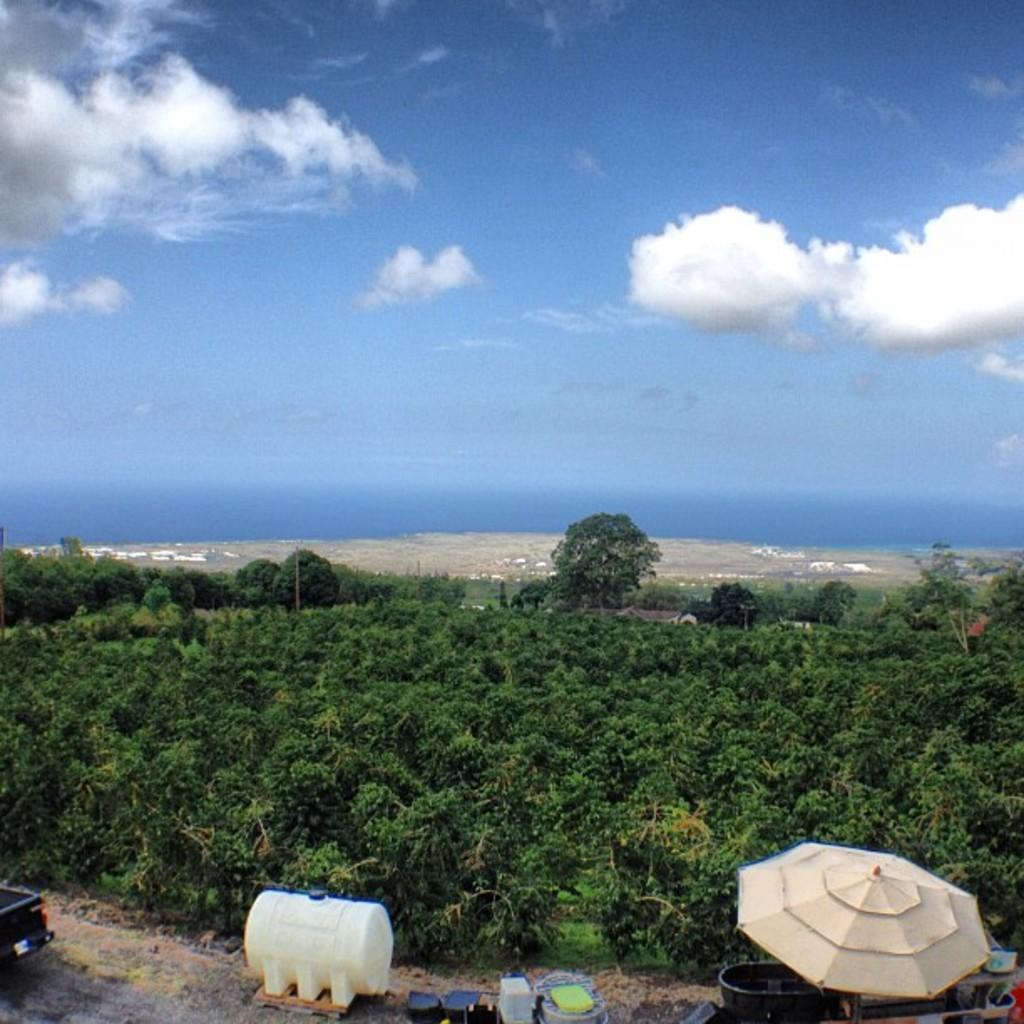Describe this image in one or two sentences. At the bottom of the image there are some objects placed on the path. In the middle of the image there are trees, plants. In the background of the image there are sky and clouds. 